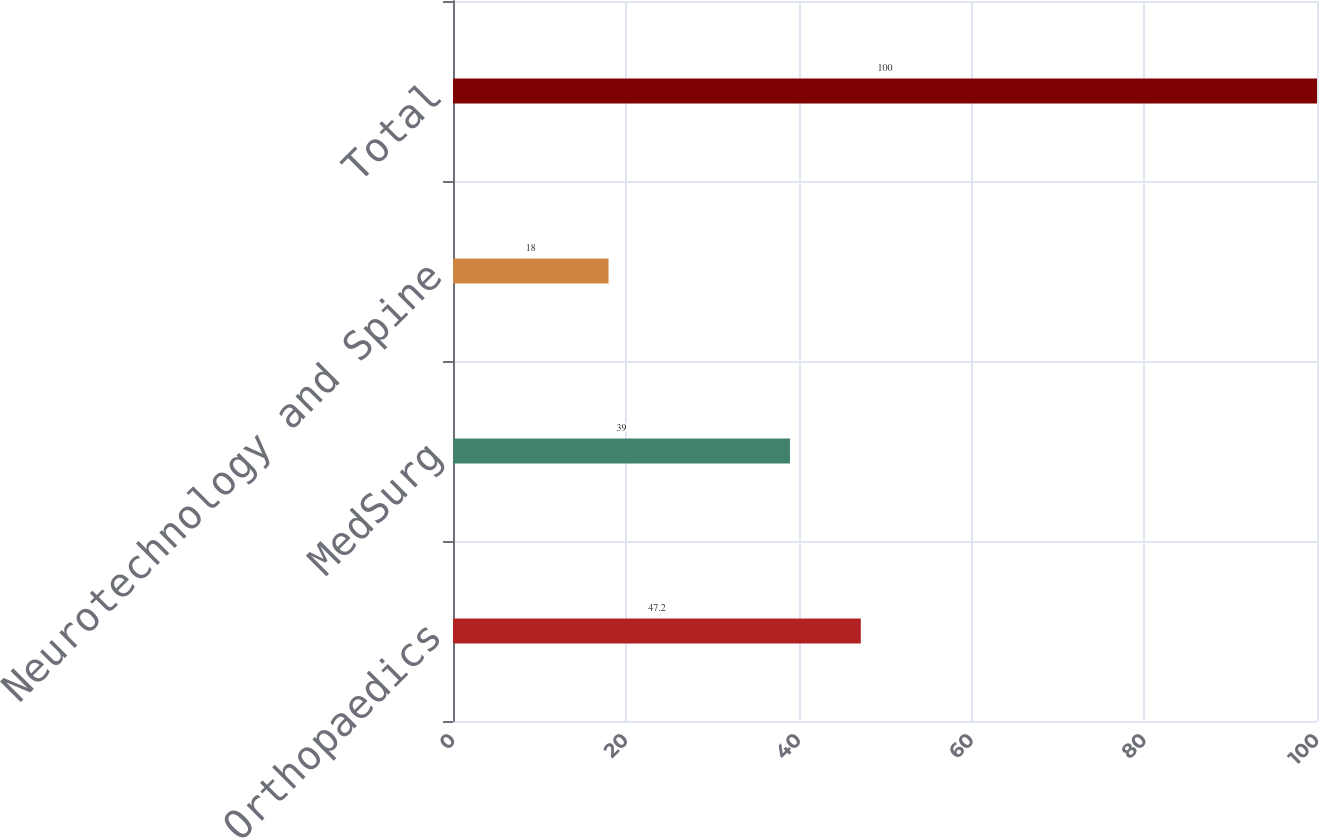Convert chart to OTSL. <chart><loc_0><loc_0><loc_500><loc_500><bar_chart><fcel>Orthopaedics<fcel>MedSurg<fcel>Neurotechnology and Spine<fcel>Total<nl><fcel>47.2<fcel>39<fcel>18<fcel>100<nl></chart> 